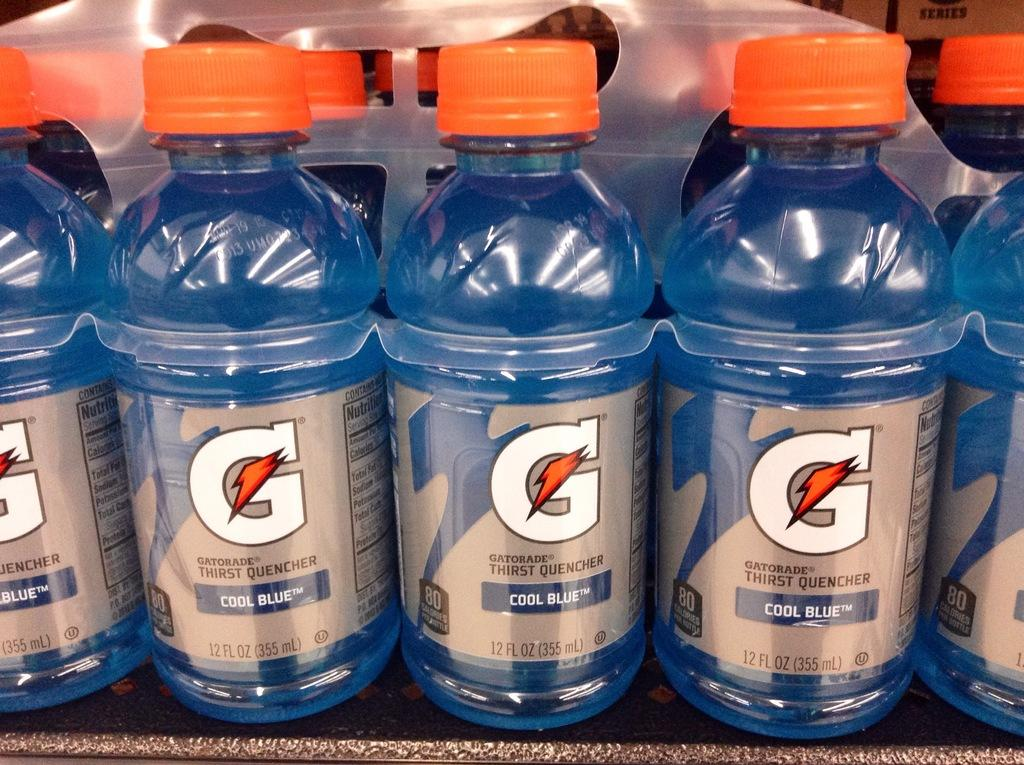<image>
Summarize the visual content of the image. a pack of small cool blue gatorade bottles 